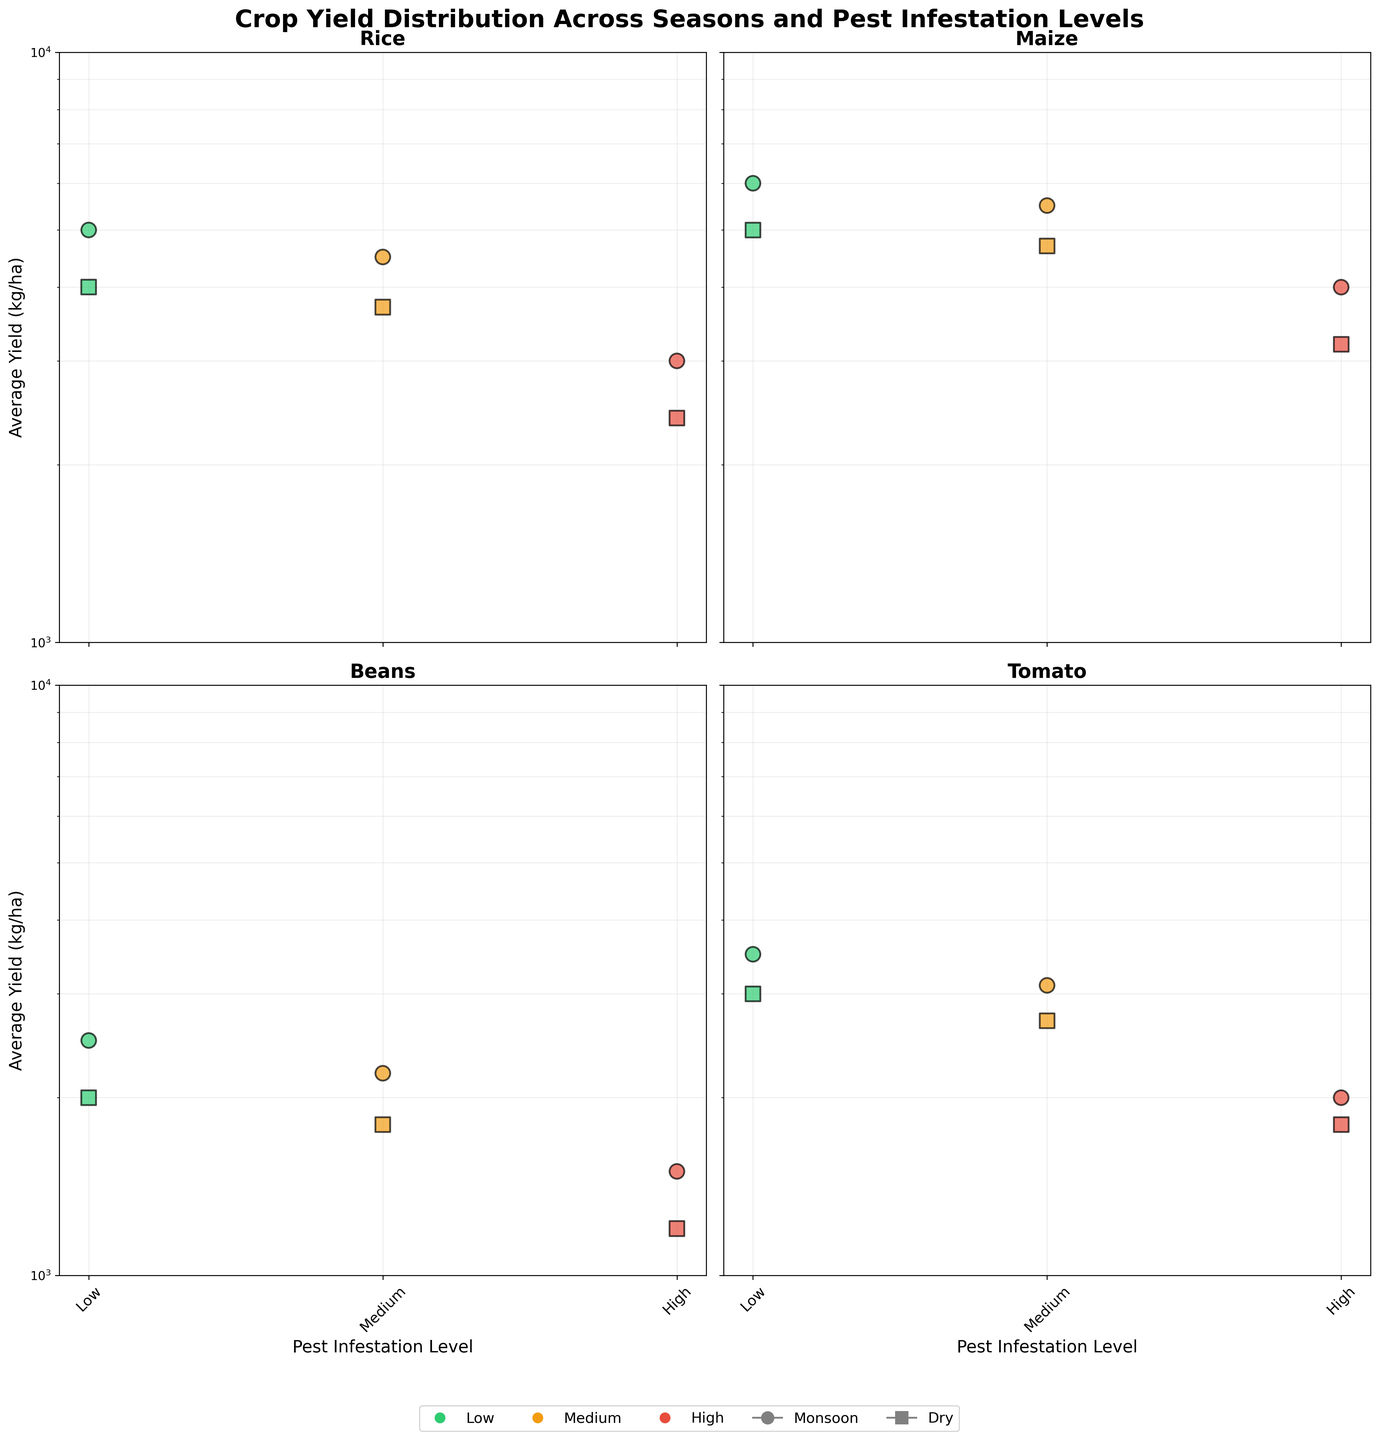What is the title of the figure? The title usually appears at the top of the figure, summarizing what the visual is about. In this case, the title is "Crop Yield Distribution Across Seasons and Pest Infestation Levels."
Answer: Crop Yield Distribution Across Seasons and Pest Infestation Levels What are the x-axis and y-axis labels? The x-axis represents the "Pest Infestation Level," which is categorized into "Low," "Medium," and "High." The y-axis represents "Average Yield (kg/ha)," indicating the yield measure for different crops under varying pest levels.
Answer: Pest Infestation Level, Average Yield (kg/ha) Which crop has the highest average yield in the Dry season with a low pest infestation level? Look at the subplots and identify which crop's marker shows the highest value on the y-axis for the Dry season (represented by square markers) under low pest infestation level (green color). For Rice, Maize, Beans, and Tomato, the highest yield is from Maize at 5000 kg/ha.
Answer: Maize For Beans, how does the yield change from low to high pest infestation during the Monsoon season? Check the subplot for Beans and compare the y-values (average yields) for low, medium, and high pest infestation levels (green, yellow, and red markers) during the Monsoon season (circular markers). The yield drops from 2500 kg/ha (low), to 2200 kg/ha (medium), to 1500 kg/ha (high).
Answer: Drops from 2500 to 1500 kg/ha Which crop is most affected by high pest infestation in the Monsoon season? Compare the decrease in yields from low to high pest infestation in the respective subplots for each crop during the Monsoon season. Rice shows a drop from 5000 kg/ha to 3000 kg/ha, Maize from 6000 to 4000 kg/ha, Beans from 2500 to 1500 kg/ha, and Tomato from 3500 to 2000 kg/ha. The highest drop is in Maize.
Answer: Maize What is the biggest difference in yield between Monsoon and Dry seasons for any crop under high pest infestation? Compare the highest yield differences between Monsoon and Dry seasons within high pest infestation values in all subplots. For Rice, it's 3000 - 2400 = 600 kg/ha. For Maize, it's 4000 - 3200 = 800 kg/ha. For Beans, it's 1500 - 1200 = 300 kg/ha. For Tomato, it's 2000 - 1800 = 200 kg/ha. The largest difference occurs with Maize.
Answer: 800 kg/ha How does the yield of Maize in the Monsoon season compare at medium and high pest infestation levels? In the subplot for Maize, examine and compare the y-values for medium and high pest infestation levels during the Monsoon season (circular markers). The values are 5500 kg/ha and 4000 kg/ha respectively.
Answer: 5500 vs 4000 kg/ha Which crop maintains the highest yield under high pest infestation in both seasons? Look at the high pest infestation markers (red) in all subplots for both Monsoon and Dry seasons, and identify the crop with the highest y-values. Maize consistently has the highest yields, with 4000 kg/ha in Monsoon and 3200 kg/ha in Dry season.
Answer: Maize 